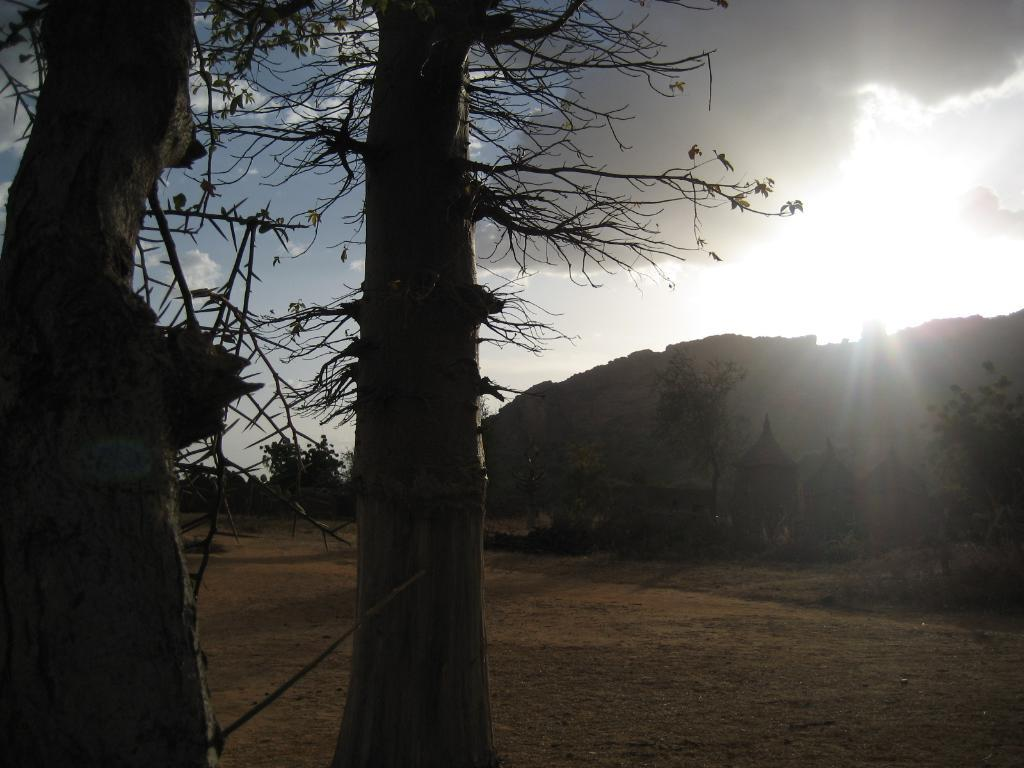What is happening with the plane in the image? The plane is landing in the image. What type of structures can be seen in the image? There are huts in the image. What other natural elements are present in the image? There are trees and a mountain in the image. What is visible in the sky in the image? The sky is visible in the image, with some clouds. What type of soup is being served in the image? There is no soup present in the image; it features a plane landing and other natural elements. What year is depicted in the image? The image does not depict a specific year; it is a snapshot of a plane landing and the surrounding environment. 